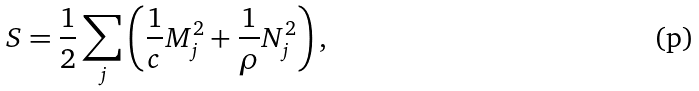<formula> <loc_0><loc_0><loc_500><loc_500>S = \frac { 1 } { 2 } \sum _ { j } \left ( \frac { 1 } { c } { M } _ { j } ^ { 2 } + \frac { 1 } { \rho } { N } _ { j } ^ { 2 } \right ) ,</formula> 